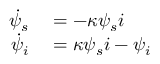Convert formula to latex. <formula><loc_0><loc_0><loc_500><loc_500>\begin{array} { r l } { \dot { \psi } _ { s } } & = - \kappa \psi _ { s } i } \\ { \dot { \psi } _ { i } } & = \kappa \psi _ { s } i - \psi _ { i } } \end{array}</formula> 